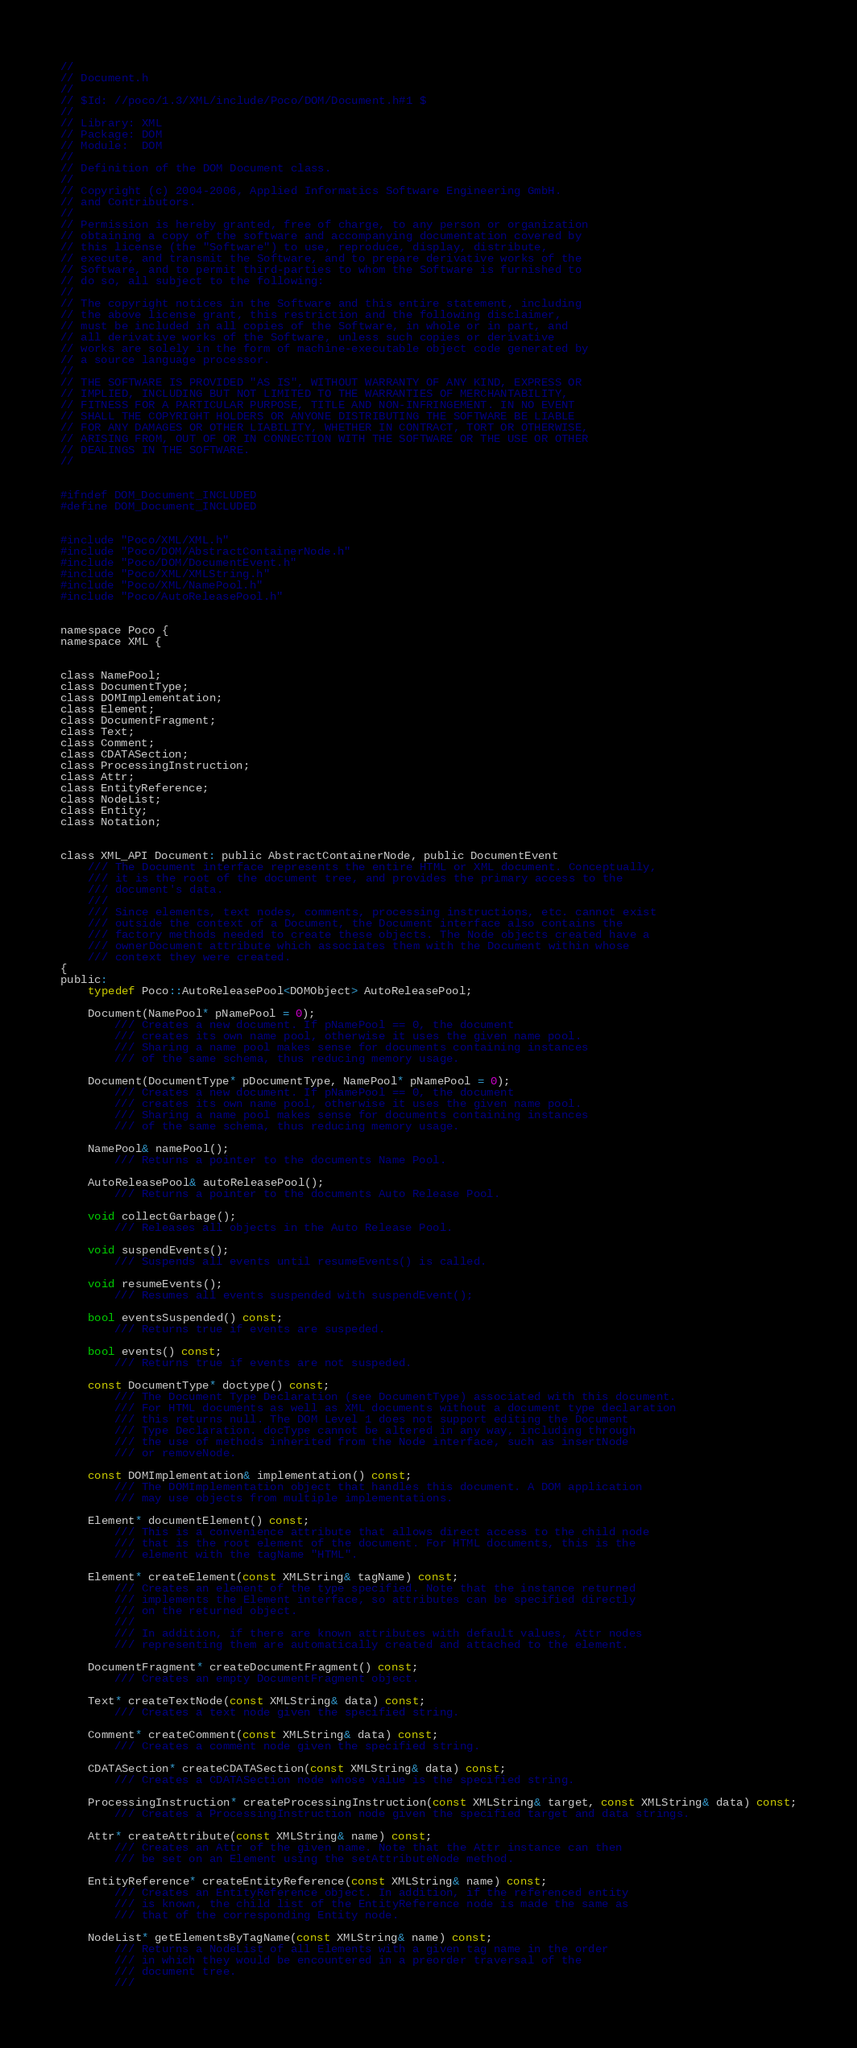<code> <loc_0><loc_0><loc_500><loc_500><_C_>//
// Document.h
//
// $Id: //poco/1.3/XML/include/Poco/DOM/Document.h#1 $
//
// Library: XML
// Package: DOM
// Module:  DOM
//
// Definition of the DOM Document class.
//
// Copyright (c) 2004-2006, Applied Informatics Software Engineering GmbH.
// and Contributors.
//
// Permission is hereby granted, free of charge, to any person or organization
// obtaining a copy of the software and accompanying documentation covered by
// this license (the "Software") to use, reproduce, display, distribute,
// execute, and transmit the Software, and to prepare derivative works of the
// Software, and to permit third-parties to whom the Software is furnished to
// do so, all subject to the following:
// 
// The copyright notices in the Software and this entire statement, including
// the above license grant, this restriction and the following disclaimer,
// must be included in all copies of the Software, in whole or in part, and
// all derivative works of the Software, unless such copies or derivative
// works are solely in the form of machine-executable object code generated by
// a source language processor.
// 
// THE SOFTWARE IS PROVIDED "AS IS", WITHOUT WARRANTY OF ANY KIND, EXPRESS OR
// IMPLIED, INCLUDING BUT NOT LIMITED TO THE WARRANTIES OF MERCHANTABILITY,
// FITNESS FOR A PARTICULAR PURPOSE, TITLE AND NON-INFRINGEMENT. IN NO EVENT
// SHALL THE COPYRIGHT HOLDERS OR ANYONE DISTRIBUTING THE SOFTWARE BE LIABLE
// FOR ANY DAMAGES OR OTHER LIABILITY, WHETHER IN CONTRACT, TORT OR OTHERWISE,
// ARISING FROM, OUT OF OR IN CONNECTION WITH THE SOFTWARE OR THE USE OR OTHER
// DEALINGS IN THE SOFTWARE.
//


#ifndef DOM_Document_INCLUDED
#define DOM_Document_INCLUDED


#include "Poco/XML/XML.h"
#include "Poco/DOM/AbstractContainerNode.h"
#include "Poco/DOM/DocumentEvent.h"
#include "Poco/XML/XMLString.h"
#include "Poco/XML/NamePool.h"
#include "Poco/AutoReleasePool.h"


namespace Poco {
namespace XML {


class NamePool;
class DocumentType;
class DOMImplementation;
class Element;
class DocumentFragment;
class Text;
class Comment;
class CDATASection;
class ProcessingInstruction;
class Attr;
class EntityReference;
class NodeList;
class Entity;
class Notation;


class XML_API Document: public AbstractContainerNode, public DocumentEvent
	/// The Document interface represents the entire HTML or XML document. Conceptually, 
	/// it is the root of the document tree, and provides the primary access to the 
	/// document's data.
	///
	/// Since elements, text nodes, comments, processing instructions, etc. cannot exist 
	/// outside the context of a Document, the Document interface also contains the 
	/// factory methods needed to create these objects. The Node objects created have a 
	/// ownerDocument attribute which associates them with the Document within whose 
	/// context they were created.
{
public:
	typedef Poco::AutoReleasePool<DOMObject> AutoReleasePool;

	Document(NamePool* pNamePool = 0);
		/// Creates a new document. If pNamePool == 0, the document
		/// creates its own name pool, otherwise it uses the given name pool.
		/// Sharing a name pool makes sense for documents containing instances
		/// of the same schema, thus reducing memory usage.

	Document(DocumentType* pDocumentType, NamePool* pNamePool = 0);
		/// Creates a new document. If pNamePool == 0, the document
		/// creates its own name pool, otherwise it uses the given name pool.
		/// Sharing a name pool makes sense for documents containing instances
		/// of the same schema, thus reducing memory usage.

	NamePool& namePool();
		/// Returns a pointer to the documents Name Pool.

	AutoReleasePool& autoReleasePool();
		/// Returns a pointer to the documents Auto Release Pool.

	void collectGarbage();
		/// Releases all objects in the Auto Release Pool.

	void suspendEvents();
		/// Suspends all events until resumeEvents() is called.

	void resumeEvents();
		/// Resumes all events suspended with suspendEvent();

	bool eventsSuspended() const;
		/// Returns true if events are suspeded.

	bool events() const;
		/// Returns true if events are not suspeded.

	const DocumentType* doctype() const;
		/// The Document Type Declaration (see DocumentType) associated with this document.
		/// For HTML documents as well as XML documents without a document type declaration
		/// this returns null. The DOM Level 1 does not support editing the Document
		/// Type Declaration. docType cannot be altered in any way, including through
		/// the use of methods inherited from the Node interface, such as insertNode
		/// or removeNode.

	const DOMImplementation& implementation() const;
		/// The DOMImplementation object that handles this document. A DOM application
		/// may use objects from multiple implementations.

	Element* documentElement() const;
		/// This is a convenience attribute that allows direct access to the child node
		/// that is the root element of the document. For HTML documents, this is the
		/// element with the tagName "HTML".

	Element* createElement(const XMLString& tagName) const;
		/// Creates an element of the type specified. Note that the instance returned
		/// implements the Element interface, so attributes can be specified directly
		/// on the returned object.
		///
		/// In addition, if there are known attributes with default values, Attr nodes
		/// representing them are automatically created and attached to the element.

	DocumentFragment* createDocumentFragment() const;
		/// Creates an empty DocumentFragment object.

	Text* createTextNode(const XMLString& data) const;
		/// Creates a text node given the specified string.

	Comment* createComment(const XMLString& data) const;
		/// Creates a comment node given the specified string.

	CDATASection* createCDATASection(const XMLString& data) const;
		/// Creates a CDATASection node whose value is the specified string.

	ProcessingInstruction* createProcessingInstruction(const XMLString& target, const XMLString& data) const;
		/// Creates a ProcessingInstruction node given the specified target and data strings.

	Attr* createAttribute(const XMLString& name) const;	
		/// Creates an Attr of the given name. Note that the Attr instance can then
		/// be set on an Element using the setAttributeNode method.	

	EntityReference* createEntityReference(const XMLString& name) const;
		/// Creates an EntityReference object. In addition, if the referenced entity
		/// is known, the child list of the EntityReference node is made the same as
		/// that of the corresponding Entity node.

	NodeList* getElementsByTagName(const XMLString& name) const;
		/// Returns a NodeList of all Elements with a given tag name in the order
		/// in which they would be encountered in a preorder traversal of the
		/// document tree.
		///</code> 